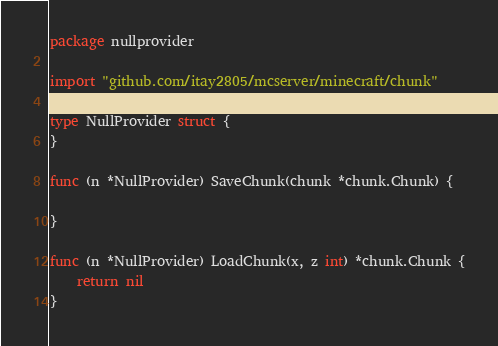<code> <loc_0><loc_0><loc_500><loc_500><_Go_>package nullprovider

import "github.com/itay2805/mcserver/minecraft/chunk"

type NullProvider struct {
}

func (n *NullProvider) SaveChunk(chunk *chunk.Chunk) {

}

func (n *NullProvider) LoadChunk(x, z int) *chunk.Chunk {
	return nil
}

</code> 